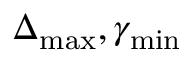<formula> <loc_0><loc_0><loc_500><loc_500>\Delta _ { \max } , \gamma _ { \min }</formula> 